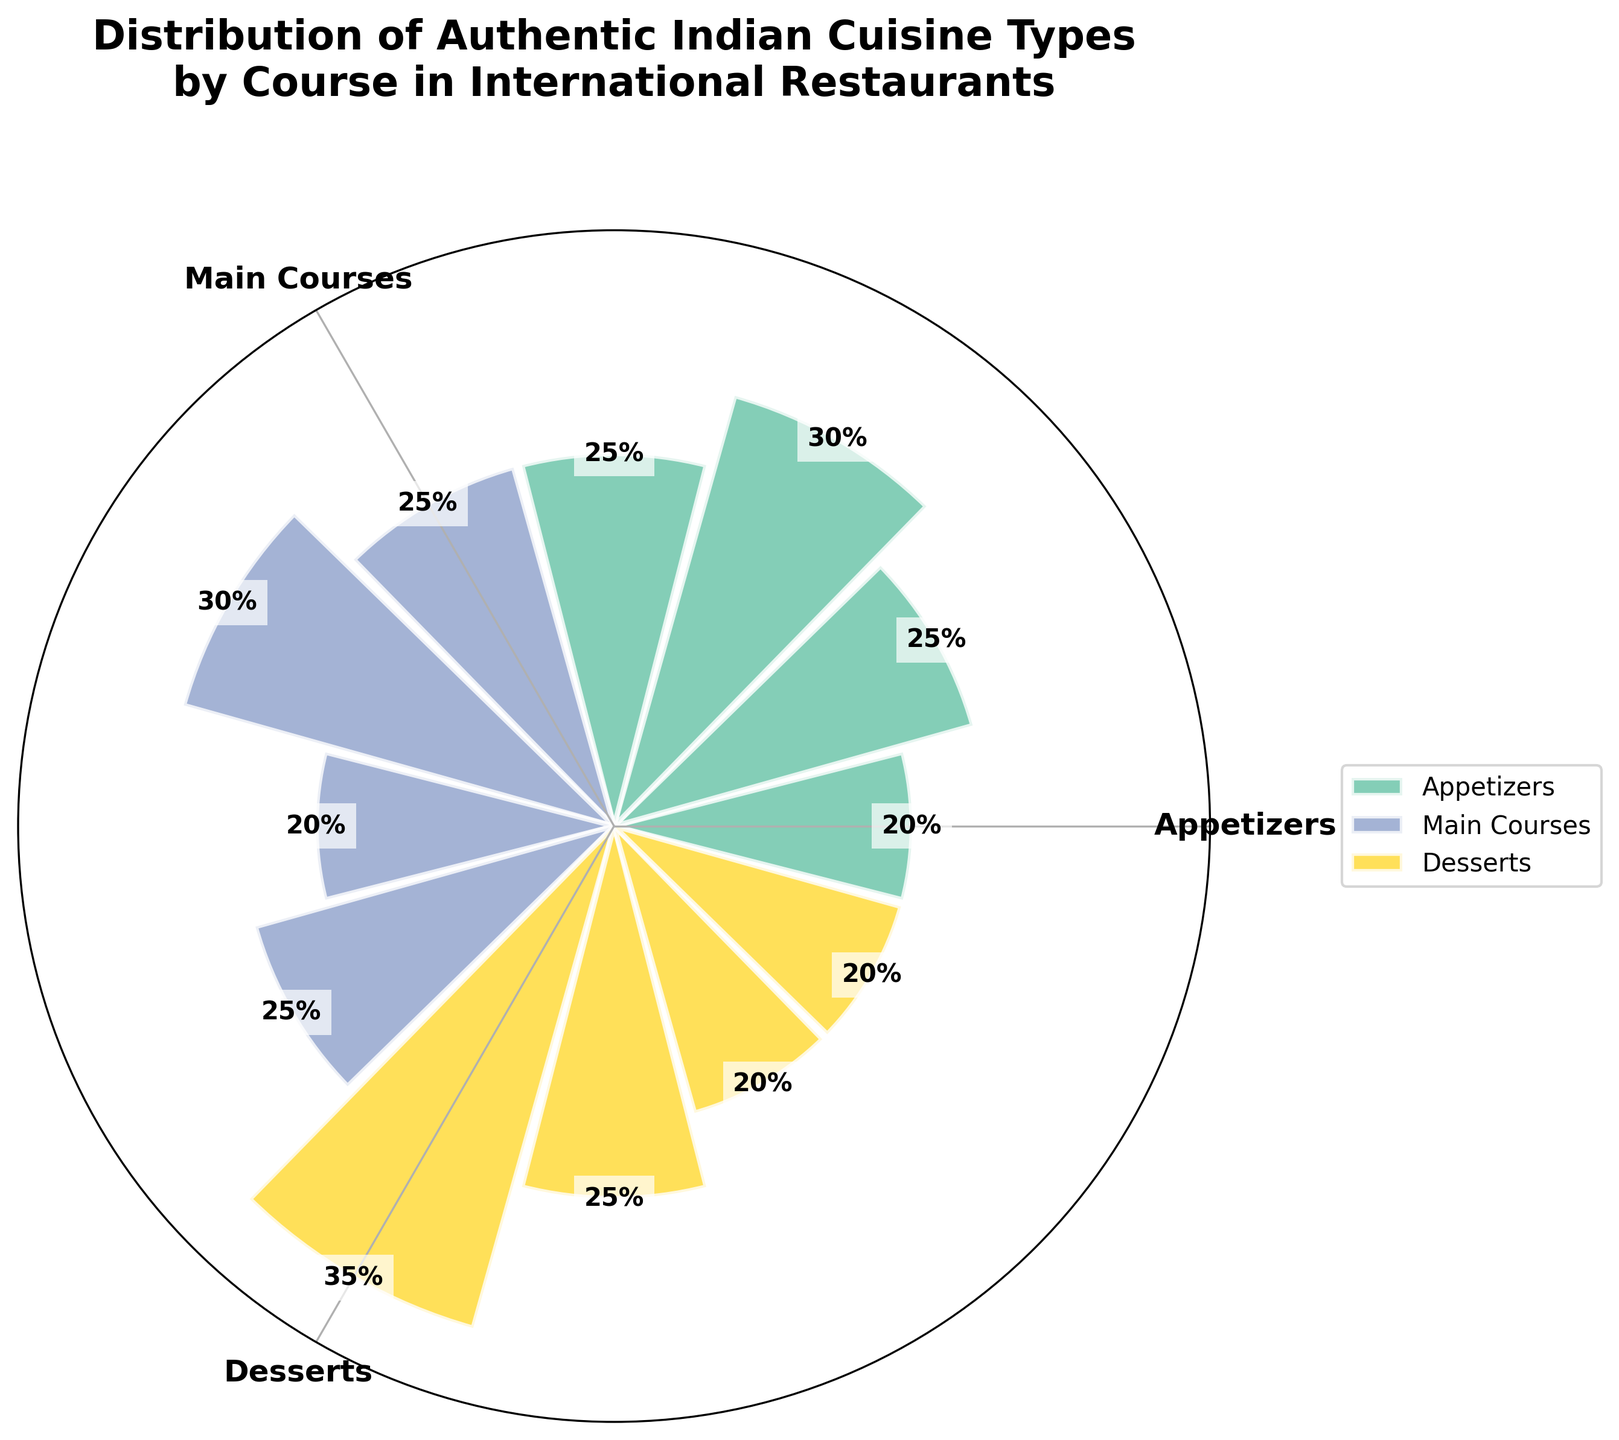What are the three courses shown in the figure? The figure title mentions "Distribution of Authentic Indian Cuisine Types by Course," which include different types of courses. By looking at the angle labels around the plot, we can see the three courses labeled "Appetizers," "Main Courses," and "Desserts."
Answer: Appetizers, Main Courses, Desserts Which dessert has the highest percentage in its category? By examining the values displayed within the sections of the "Desserts" category, "Gulab Jamun" consistently has the highest percentage at 35%.
Answer: Gulab Jamun What is the combined percentage of Samosa and Pakora in the Appetizers category? In the Appetizers category, "Samosa" has a percentage of 20%, and "Pakora" has a percentage of 25%. Adding these percentages gives 20% + 25% = 45%.
Answer: 45% Which main course has the lowest percentage? By looking at the percentages of the various dishes within the "Main Courses" category, we see that "Rogan Josh" has the lowest percentage at 20%.
Answer: Rogan Josh Compare the proportion of Paneer Tikka and Dal Makhani. Which one is more prevalent? Within the "Appetizers" category, "Paneer Tikka" has a percentage of 30%, while within the "Main Courses" category, "Dal Makhani" has a percentage of 25%. Therefore, "Paneer Tikka" is more prevalent.
Answer: Paneer Tikka What's the difference in percentage between the highest and lowest valued desserts? The highest-valued dessert is "Gulab Jamun" at 35%, and the lowest-valued desserts are "Kulfi" and "Jalebi" at 20%. The difference is 35% - 20% = 15%.
Answer: 15% Which category has the most evenly distributed types, and why? By observing the percentage values of each type in the categories, the "Appetizers" category has Samosa (20%), Pakora (25%), Paneer Tikka (30%), and Aloo Tikki (25%). This distribution shows relatively similar percentages compared to other categories.
Answer: Appetizers If you combine the percentages of all the Main Courses, what would the total percentage be? Calculating the sum of all the percentages in the "Main Courses" category: Butter Chicken (25%) + Biryani (30%) + Rogan Josh (20%) + Dal Makhani (25%), we get 25% + 30% + 20% + 25% = 100%.
Answer: 100% What is the most popular cuisine item overall and in which course does it belong? From the plot, "Gulab Jamun" within the "Desserts" category has the highest percentage at 35%. Therefore, it is the most popular cuisine item overall and belongs to the Desserts course.
Answer: Gulab Jamun, Desserts 